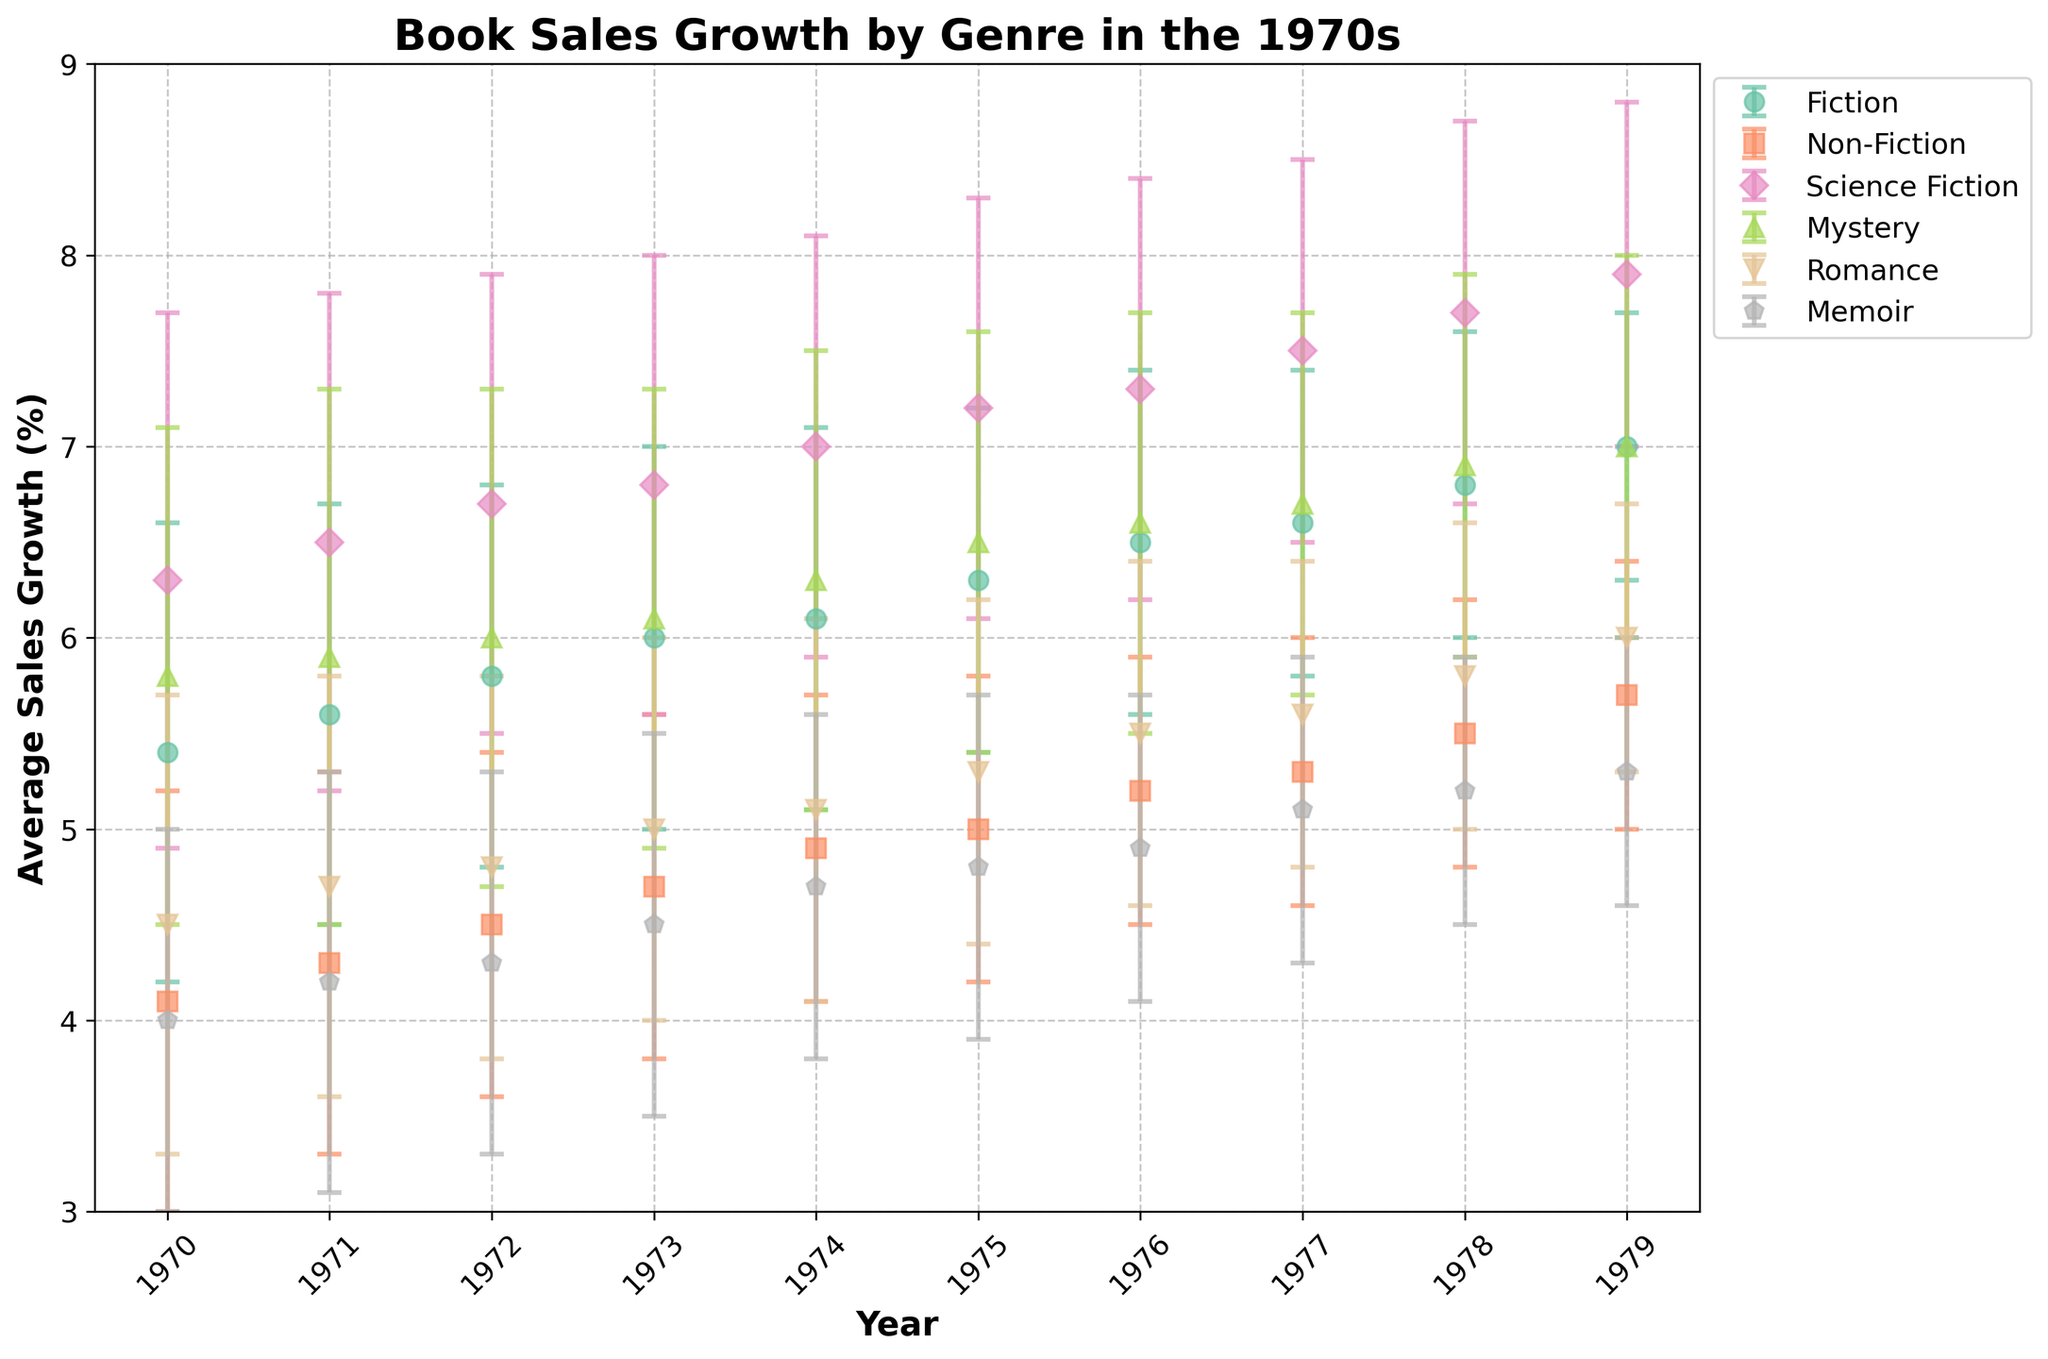What's the title of the figure? The title of the figure is usually located at the top and prominently displayed. In this figure, it reads 'Book Sales Growth by Genre in the 1970s'.
Answer: Book Sales Growth by Genre in the 1970s Which genre had the highest average sales growth in 1979? To find the genre with the highest average sales growth in 1979, look at the data points for that year. Science Fiction has the highest average sales growth at 7.9%.
Answer: Science Fiction Which genre displayed the most consistent growth throughout the 1970s based on the error bars? The genre with the most consistent growth will have the smallest error bars over time. Memoir shows the smallest error bars consistently throughout the 1970s.
Answer: Memoir What was the average sales growth of Fiction in 1975 and how does it compare to 1970? Find the data points for Fiction in 1975 and 1970 and compare them. In 1975, Fiction's average sales growth was 6.3%, and in 1970, it was 5.4%. Thus, there is a difference of 0.9%.
Answer: 6.3%, increased by 0.9% Which year saw the highest overall average sales growth across all genres? To determine the highest overall average sales growth, look at each year and find the year with the highest average sales growth value. 1979 has the highest sales growth in multiple genres, with the maximum being Science Fiction at 7.9%.
Answer: 1979 Did any genre see a constant increase in sales from 1970 to 1979? Analyzing each genre's trend from 1970 to 1979, Fiction saw an increase each year starting from 5.4% in 1970 to 7.0% in 1979.
Answer: Fiction What is the standard error for Non-Fiction in 1974? The standard error is depicted as the length of the error bars from the point. For Non-Fiction in 1974, the standard error is 0.8.
Answer: 0.8 Compare the sales growth trends of Science Fiction and Romance over the 1970s. Which genre showed a larger increase, and by how much? Calculate the difference between the starting and ending average sales growth for both genres. Science Fiction increased from 6.3% (1970) to 7.9% (1979), a gain of 1.6%. Romance went from 4.5% (1970) to 6.0% (1979), a gain of 1.5%. Science Fiction had a larger increase by 0.1%.
Answer: Science Fiction increased more by 0.1% What was the lowest average sales growth for Mystery in the 1970s, and in which year did it occur? Look at the data points for Mystery. The lowest value is 5.8% in 1970.
Answer: 5.8%, in 1970 